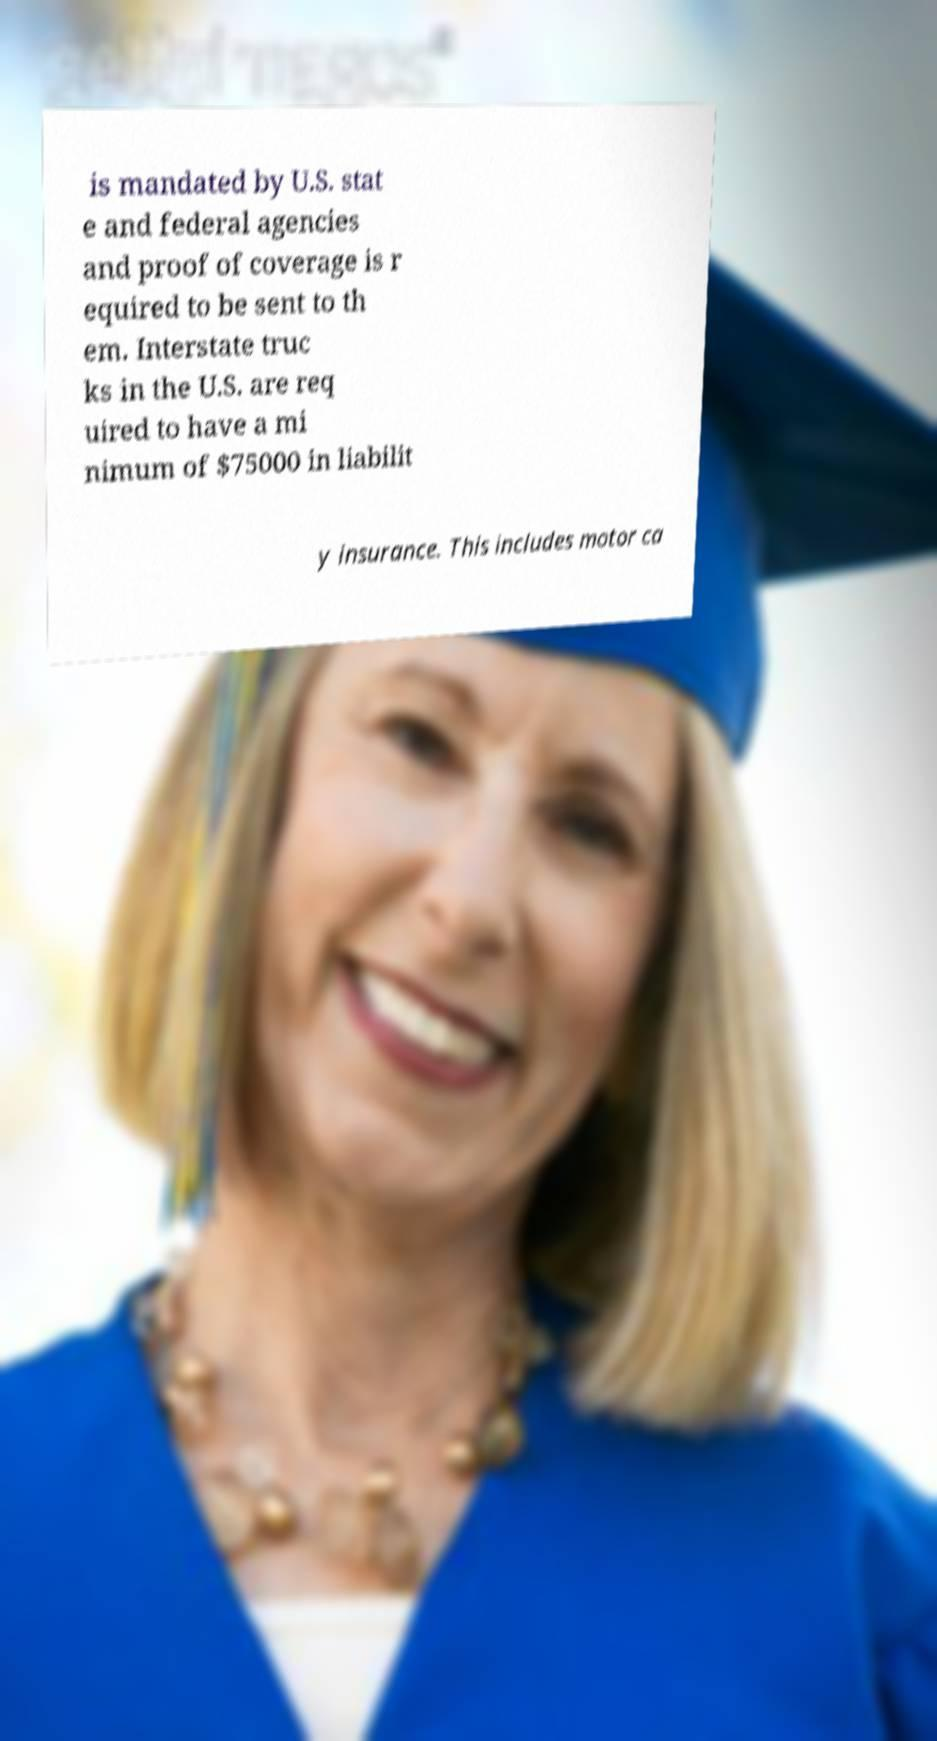Can you read and provide the text displayed in the image?This photo seems to have some interesting text. Can you extract and type it out for me? is mandated by U.S. stat e and federal agencies and proof of coverage is r equired to be sent to th em. Interstate truc ks in the U.S. are req uired to have a mi nimum of $75000 in liabilit y insurance. This includes motor ca 